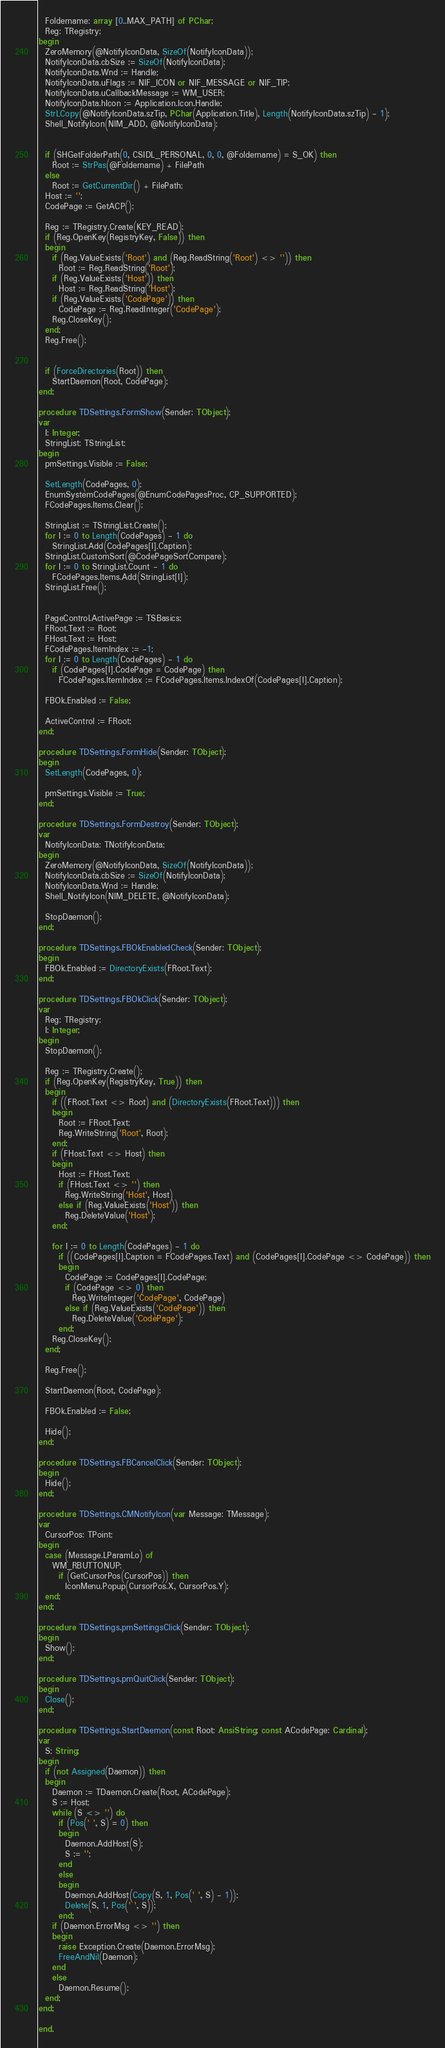Convert code to text. <code><loc_0><loc_0><loc_500><loc_500><_Pascal_>  Foldername: array [0..MAX_PATH] of PChar;
  Reg: TRegistry;
begin
  ZeroMemory(@NotifyIconData, SizeOf(NotifyIconData));
  NotifyIconData.cbSize := SizeOf(NotifyIconData);
  NotifyIconData.Wnd := Handle;
  NotifyIconData.uFlags := NIF_ICON or NIF_MESSAGE or NIF_TIP;
  NotifyIconData.uCallbackMessage := WM_USER;
  NotifyIconData.hIcon := Application.Icon.Handle;
  StrLCopy(@NotifyIconData.szTip, PChar(Application.Title), Length(NotifyIconData.szTip) - 1);
  Shell_NotifyIcon(NIM_ADD, @NotifyIconData);


  if (SHGetFolderPath(0, CSIDL_PERSONAL, 0, 0, @Foldername) = S_OK) then
    Root := StrPas(@Foldername) + FilePath
  else
    Root := GetCurrentDir() + FilePath;
  Host := '';
  CodePage := GetACP();

  Reg := TRegistry.Create(KEY_READ);
  if (Reg.OpenKey(RegistryKey, False)) then
  begin
    if (Reg.ValueExists('Root') and (Reg.ReadString('Root') <> '')) then
      Root := Reg.ReadString('Root');
    if (Reg.ValueExists('Host')) then
      Host := Reg.ReadString('Host');
    if (Reg.ValueExists('CodePage')) then
      CodePage := Reg.ReadInteger('CodePage');
    Reg.CloseKey();
  end;
  Reg.Free();


  if (ForceDirectories(Root)) then
    StartDaemon(Root, CodePage);
end;

procedure TDSettings.FormShow(Sender: TObject);
var
  I: Integer;
  StringList: TStringList;
begin
  pmSettings.Visible := False;

  SetLength(CodePages, 0);
  EnumSystemCodePages(@EnumCodePagesProc, CP_SUPPORTED);
  FCodePages.Items.Clear();

  StringList := TStringList.Create();
  for I := 0 to Length(CodePages) - 1 do
    StringList.Add(CodePages[I].Caption);
  StringList.CustomSort(@CodePageSortCompare);
  for I := 0 to StringList.Count - 1 do
    FCodePages.Items.Add(StringList[I]);
  StringList.Free();


  PageControl.ActivePage := TSBasics;
  FRoot.Text := Root;
  FHost.Text := Host;
  FCodePages.ItemIndex := -1;
  for I := 0 to Length(CodePages) - 1 do
    if (CodePages[I].CodePage = CodePage) then
      FCodePages.ItemIndex := FCodePages.Items.IndexOf(CodePages[I].Caption);

  FBOk.Enabled := False;

  ActiveControl := FRoot;
end;

procedure TDSettings.FormHide(Sender: TObject);
begin
  SetLength(CodePages, 0);

  pmSettings.Visible := True;
end;

procedure TDSettings.FormDestroy(Sender: TObject);
var
  NotifyIconData: TNotifyIconData;
begin
  ZeroMemory(@NotifyIconData, SizeOf(NotifyIconData));
  NotifyIconData.cbSize := SizeOf(NotifyIconData);
  NotifyIconData.Wnd := Handle;
  Shell_NotifyIcon(NIM_DELETE, @NotifyIconData);

  StopDaemon();
end;

procedure TDSettings.FBOkEnabledCheck(Sender: TObject);
begin
  FBOk.Enabled := DirectoryExists(FRoot.Text);
end;

procedure TDSettings.FBOkClick(Sender: TObject);
var
  Reg: TRegistry;
  I: Integer;
begin
  StopDaemon();

  Reg := TRegistry.Create();
  if (Reg.OpenKey(RegistryKey, True)) then
  begin
    if ((FRoot.Text <> Root) and (DirectoryExists(FRoot.Text))) then
    begin
      Root := FRoot.Text;
      Reg.WriteString('Root', Root);
    end;
    if (FHost.Text <> Host) then
    begin
      Host := FHost.Text;
      if (FHost.Text <> '') then
        Reg.WriteString('Host', Host)
      else if (Reg.ValueExists('Host')) then
        Reg.DeleteValue('Host');
    end;

    for I := 0 to Length(CodePages) - 1 do
      if ((CodePages[I].Caption = FCodePages.Text) and (CodePages[I].CodePage <> CodePage)) then
      begin
        CodePage := CodePages[I].CodePage;
        if (CodePage <> 0) then
          Reg.WriteInteger('CodePage', CodePage)
        else if (Reg.ValueExists('CodePage')) then
          Reg.DeleteValue('CodePage');
      end;
    Reg.CloseKey();
  end;

  Reg.Free();

  StartDaemon(Root, CodePage);

  FBOk.Enabled := False;

  Hide();
end;

procedure TDSettings.FBCancelClick(Sender: TObject);
begin
  Hide();
end;

procedure TDSettings.CMNotifyIcon(var Message: TMessage);
var
  CursorPos: TPoint;
begin
  case (Message.LParamLo) of
    WM_RBUTTONUP:
      if (GetCursorPos(CursorPos)) then
        IconMenu.Popup(CursorPos.X, CursorPos.Y);
  end;
end;

procedure TDSettings.pmSettingsClick(Sender: TObject);
begin
  Show();
end;

procedure TDSettings.pmQuitClick(Sender: TObject);
begin
  Close();
end;

procedure TDSettings.StartDaemon(const Root: AnsiString; const ACodePage: Cardinal);
var
  S: String;
begin
  if (not Assigned(Daemon)) then
  begin
    Daemon := TDaemon.Create(Root, ACodePage);
    S := Host;
    while (S <> '') do
      if (Pos(' ', S) = 0) then
      begin
        Daemon.AddHost(S);
        S := '';
      end
      else
      begin
        Daemon.AddHost(Copy(S, 1, Pos(' ', S) - 1));
        Delete(S, 1, Pos(' ', S));
      end;
    if (Daemon.ErrorMsg <> '') then
    begin
      raise Exception.Create(Daemon.ErrorMsg);
      FreeAndNil(Daemon);
    end
    else
      Daemon.Resume();
  end;
end;

end.
</code> 